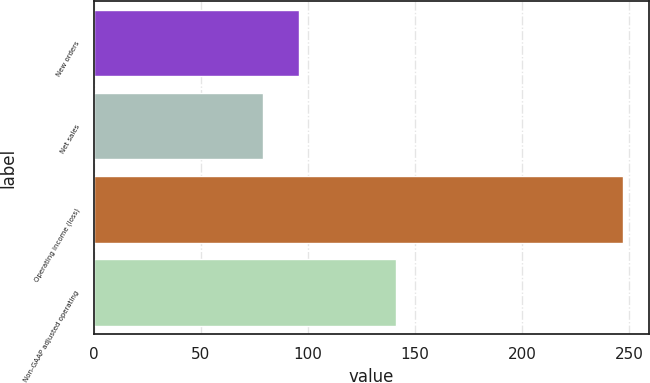Convert chart. <chart><loc_0><loc_0><loc_500><loc_500><bar_chart><fcel>New orders<fcel>Net sales<fcel>Operating income (loss)<fcel>Non-GAAP adjusted operating<nl><fcel>95.8<fcel>79<fcel>247<fcel>141<nl></chart> 